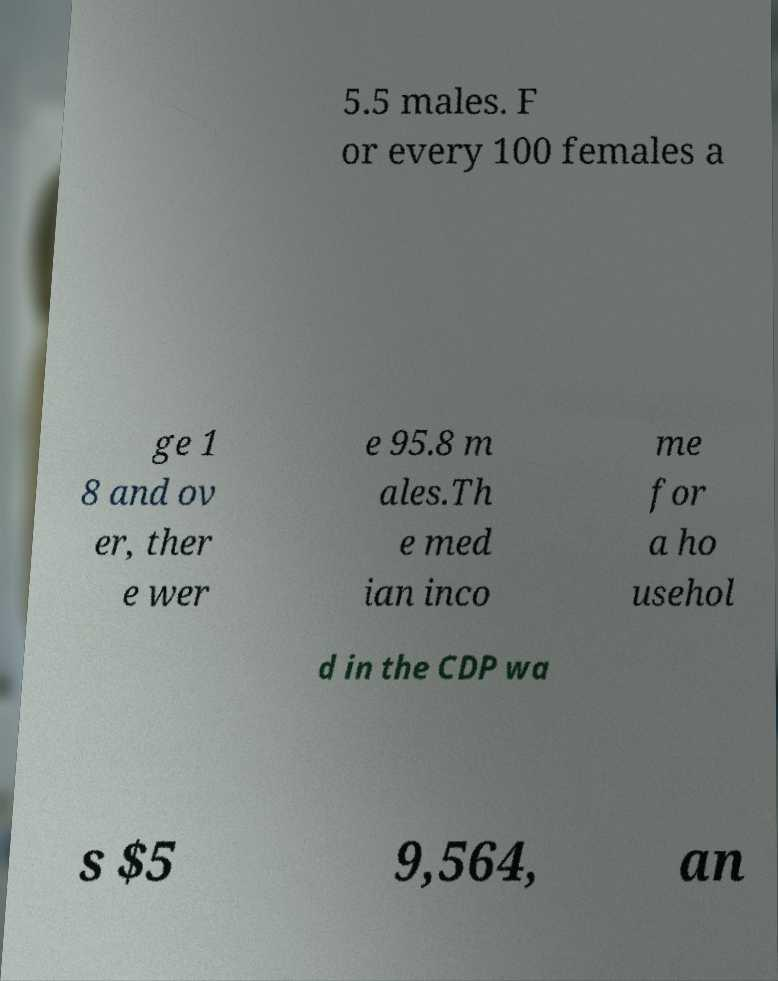Can you accurately transcribe the text from the provided image for me? 5.5 males. F or every 100 females a ge 1 8 and ov er, ther e wer e 95.8 m ales.Th e med ian inco me for a ho usehol d in the CDP wa s $5 9,564, an 